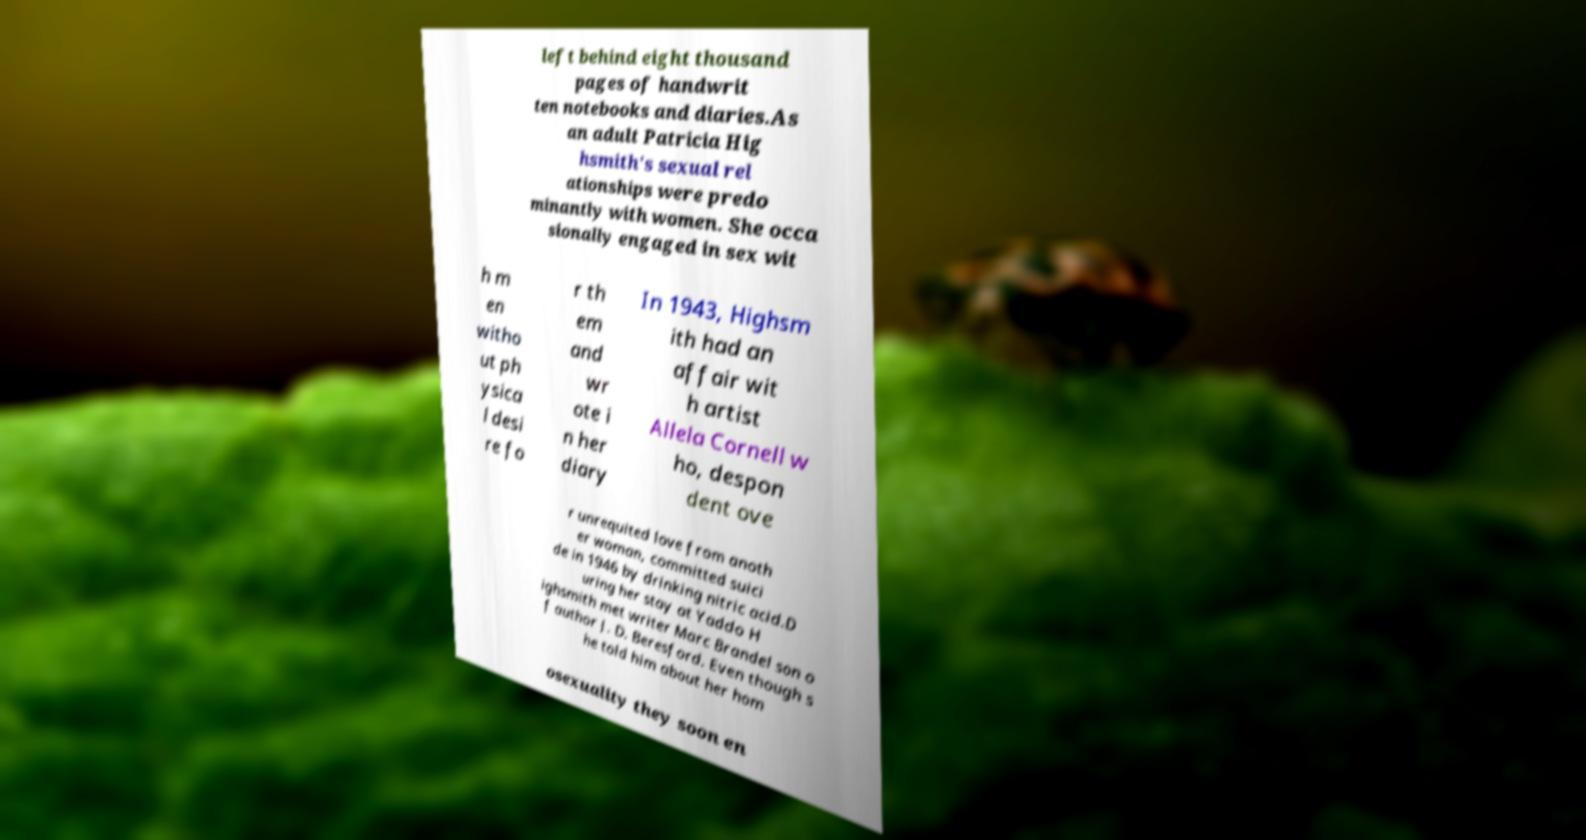Could you assist in decoding the text presented in this image and type it out clearly? left behind eight thousand pages of handwrit ten notebooks and diaries.As an adult Patricia Hig hsmith's sexual rel ationships were predo minantly with women. She occa sionally engaged in sex wit h m en witho ut ph ysica l desi re fo r th em and wr ote i n her diary In 1943, Highsm ith had an affair wit h artist Allela Cornell w ho, despon dent ove r unrequited love from anoth er woman, committed suici de in 1946 by drinking nitric acid.D uring her stay at Yaddo H ighsmith met writer Marc Brandel son o f author J. D. Beresford. Even though s he told him about her hom osexuality they soon en 